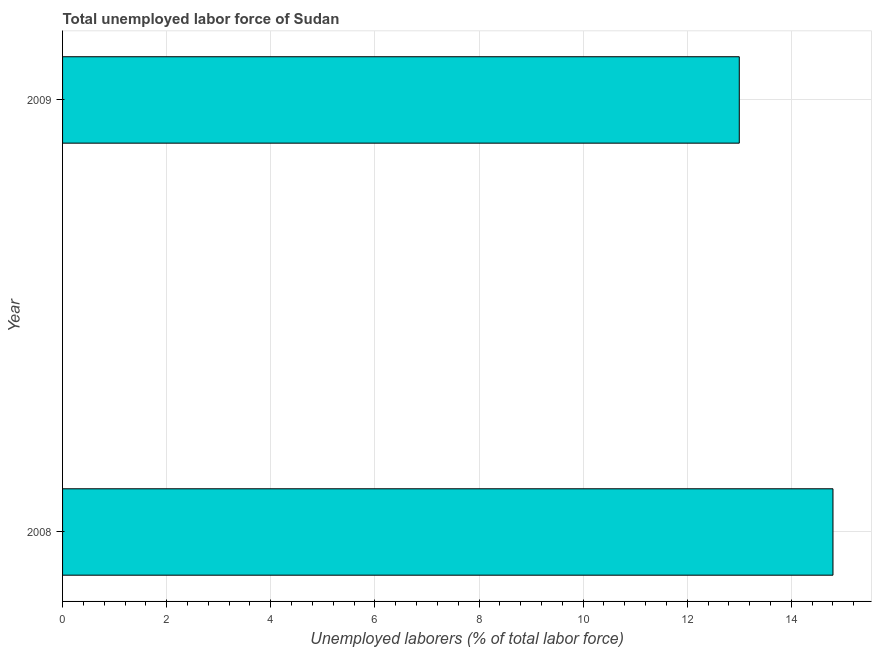What is the title of the graph?
Provide a short and direct response. Total unemployed labor force of Sudan. What is the label or title of the X-axis?
Provide a short and direct response. Unemployed laborers (% of total labor force). What is the total unemployed labour force in 2008?
Provide a short and direct response. 14.8. Across all years, what is the maximum total unemployed labour force?
Give a very brief answer. 14.8. In which year was the total unemployed labour force maximum?
Ensure brevity in your answer.  2008. What is the sum of the total unemployed labour force?
Your answer should be very brief. 27.8. What is the average total unemployed labour force per year?
Your answer should be compact. 13.9. What is the median total unemployed labour force?
Offer a terse response. 13.9. Do a majority of the years between 2008 and 2009 (inclusive) have total unemployed labour force greater than 10.8 %?
Provide a short and direct response. Yes. What is the ratio of the total unemployed labour force in 2008 to that in 2009?
Make the answer very short. 1.14. Is the total unemployed labour force in 2008 less than that in 2009?
Provide a succinct answer. No. In how many years, is the total unemployed labour force greater than the average total unemployed labour force taken over all years?
Your answer should be compact. 1. How many bars are there?
Offer a terse response. 2. Are all the bars in the graph horizontal?
Offer a very short reply. Yes. How many years are there in the graph?
Keep it short and to the point. 2. What is the difference between two consecutive major ticks on the X-axis?
Provide a succinct answer. 2. Are the values on the major ticks of X-axis written in scientific E-notation?
Your answer should be compact. No. What is the Unemployed laborers (% of total labor force) in 2008?
Your response must be concise. 14.8. What is the Unemployed laborers (% of total labor force) in 2009?
Your answer should be very brief. 13. What is the ratio of the Unemployed laborers (% of total labor force) in 2008 to that in 2009?
Your response must be concise. 1.14. 